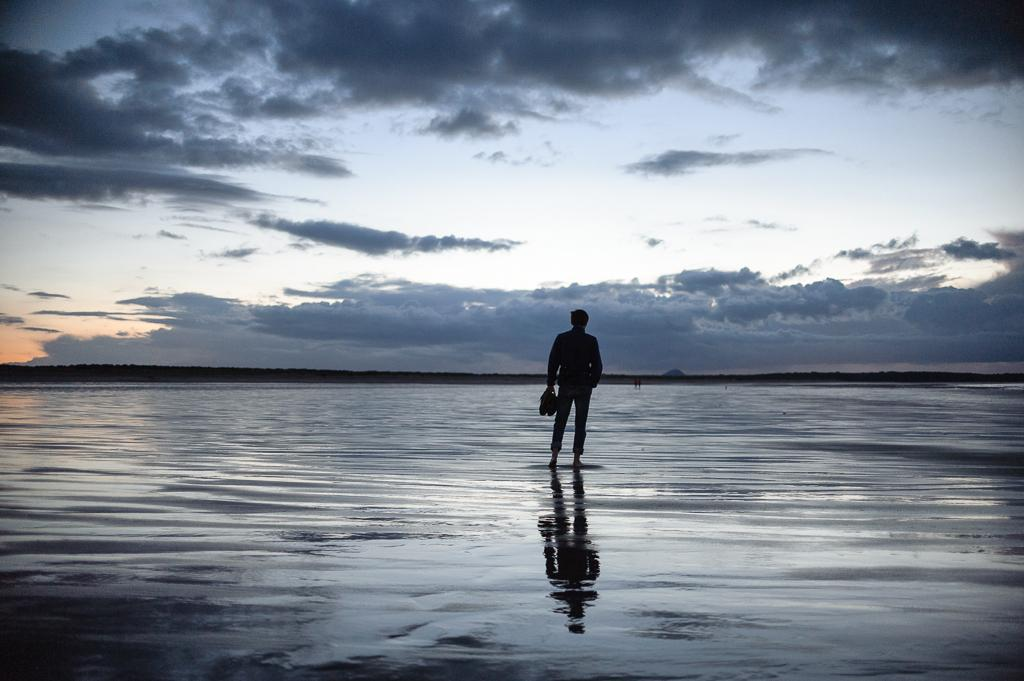What is the man in the image doing? The man is standing in the image and holding a pair of shoes. What is the condition of the floor in the image? There is water on the floor in the image. What is the weather like in the image? The sky is clear in the image, suggesting good weather. What type of gold discovery can be seen in the image? There is no gold discovery present in the image; it features a man holding a pair of shoes and water on the floor. What religious symbol is depicted in the image? There is no religious symbol present in the image. 